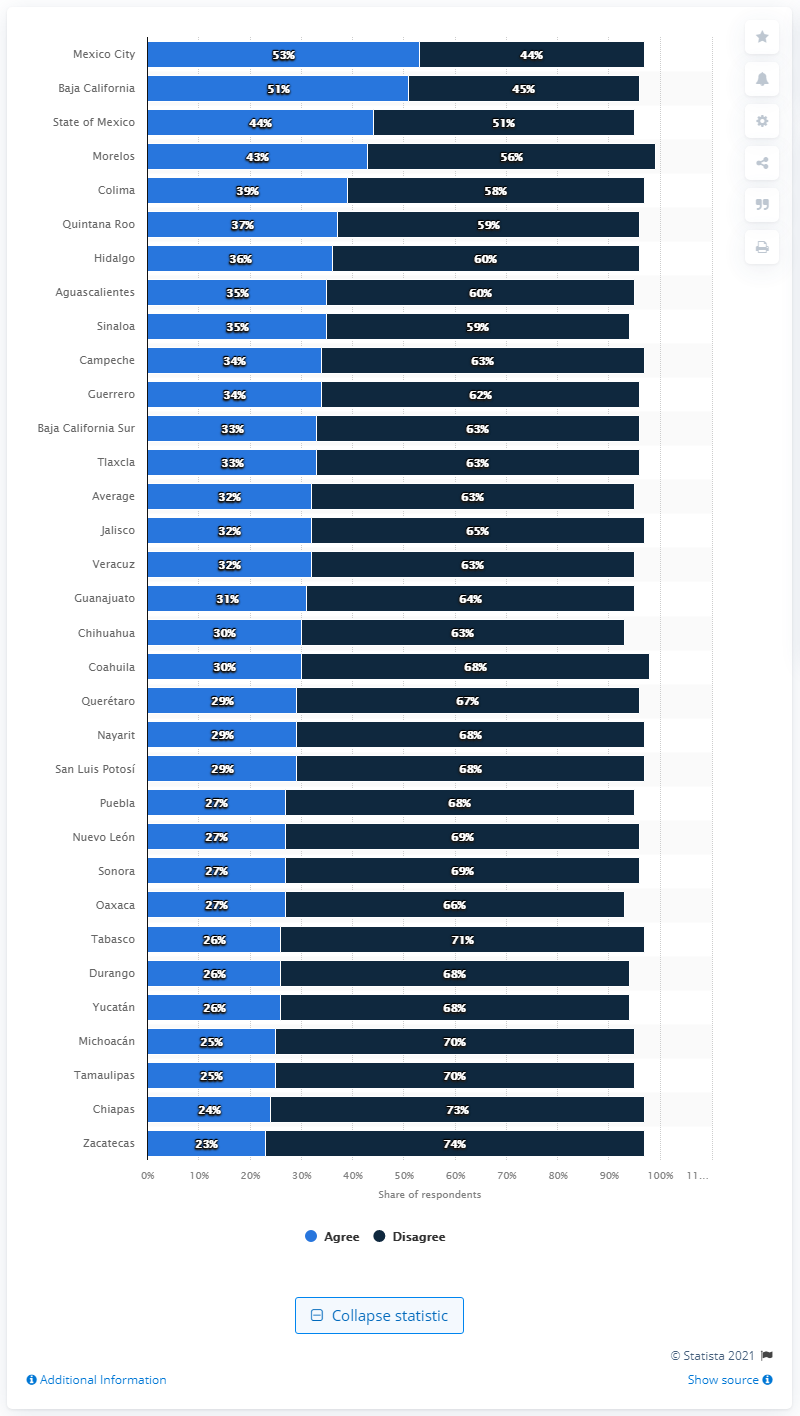Give some essential details in this illustration. In 2019, the state of Oaxaca decriminalized abortion. 